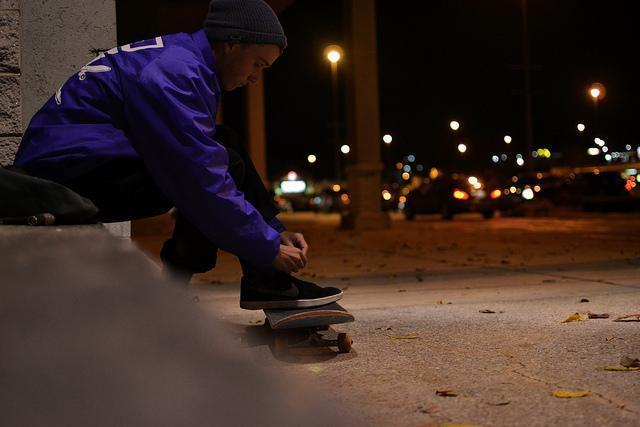How many wheels are on the skateboard?
Give a very brief answer. 4. 